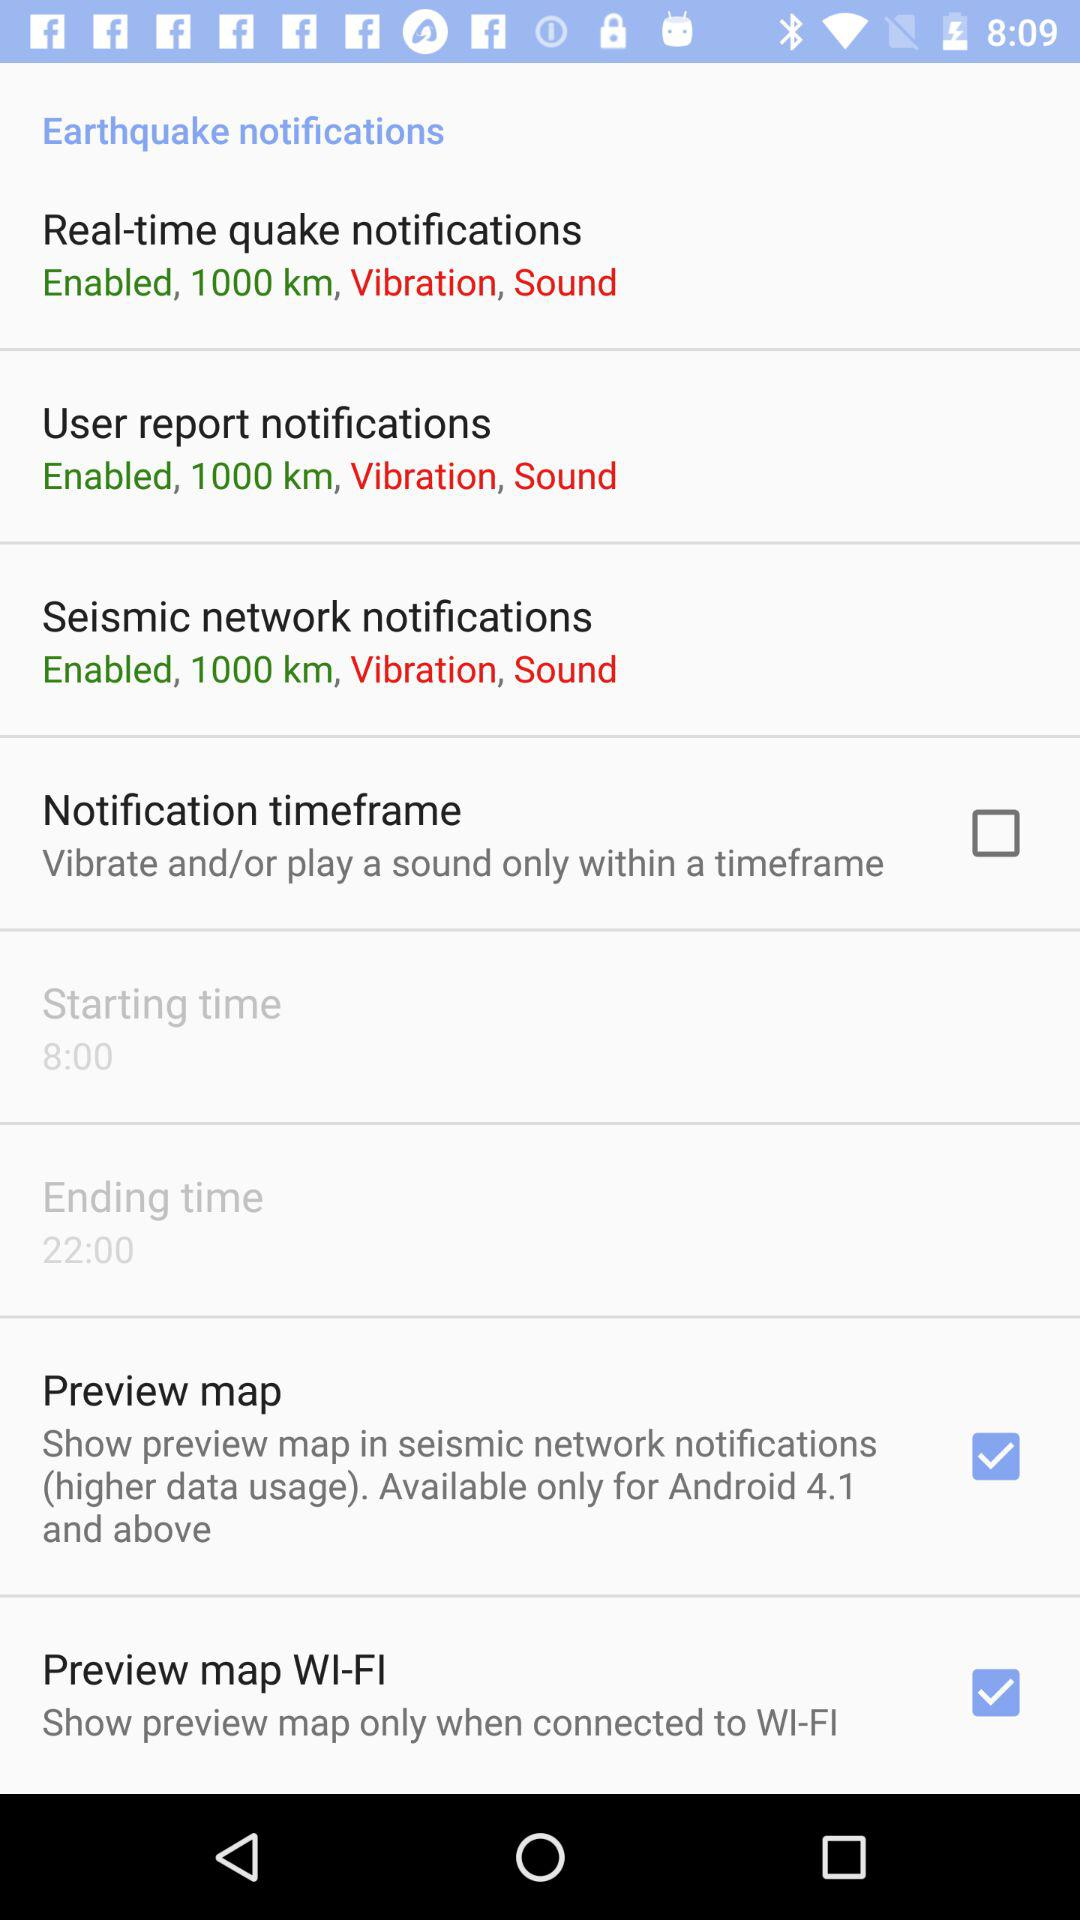How many types of notifications are there?
Answer the question using a single word or phrase. 3 